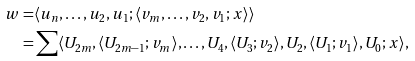Convert formula to latex. <formula><loc_0><loc_0><loc_500><loc_500>w = & \langle u _ { n } , \dots , u _ { 2 } , u _ { 1 } ; \langle v _ { m } , \dots , v _ { 2 } , v _ { 1 } ; x \rangle \rangle \\ = & \sum \langle U _ { 2 m } , \langle U _ { 2 m - 1 } ; v _ { m } \rangle , \dots , U _ { 4 } , \langle U _ { 3 } ; v _ { 2 } \rangle , U _ { 2 } , \langle U _ { 1 } ; v _ { 1 } \rangle , U _ { 0 } ; x \rangle ,</formula> 